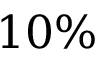Convert formula to latex. <formula><loc_0><loc_0><loc_500><loc_500>1 0 \%</formula> 